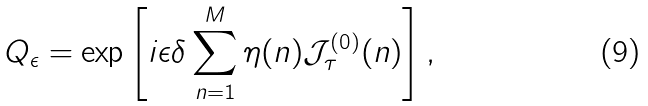<formula> <loc_0><loc_0><loc_500><loc_500>Q _ { \epsilon } = \exp \left [ i \epsilon \delta \sum _ { n = 1 } ^ { M } \eta ( n ) \mathcal { J } _ { \tau } ^ { ( 0 ) } ( n ) \right ] ,</formula> 